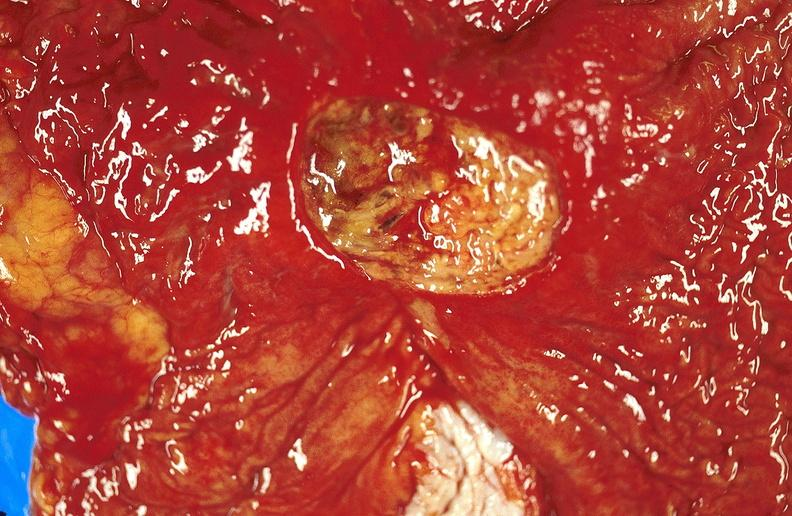s polyarteritis nodosa present?
Answer the question using a single word or phrase. No 